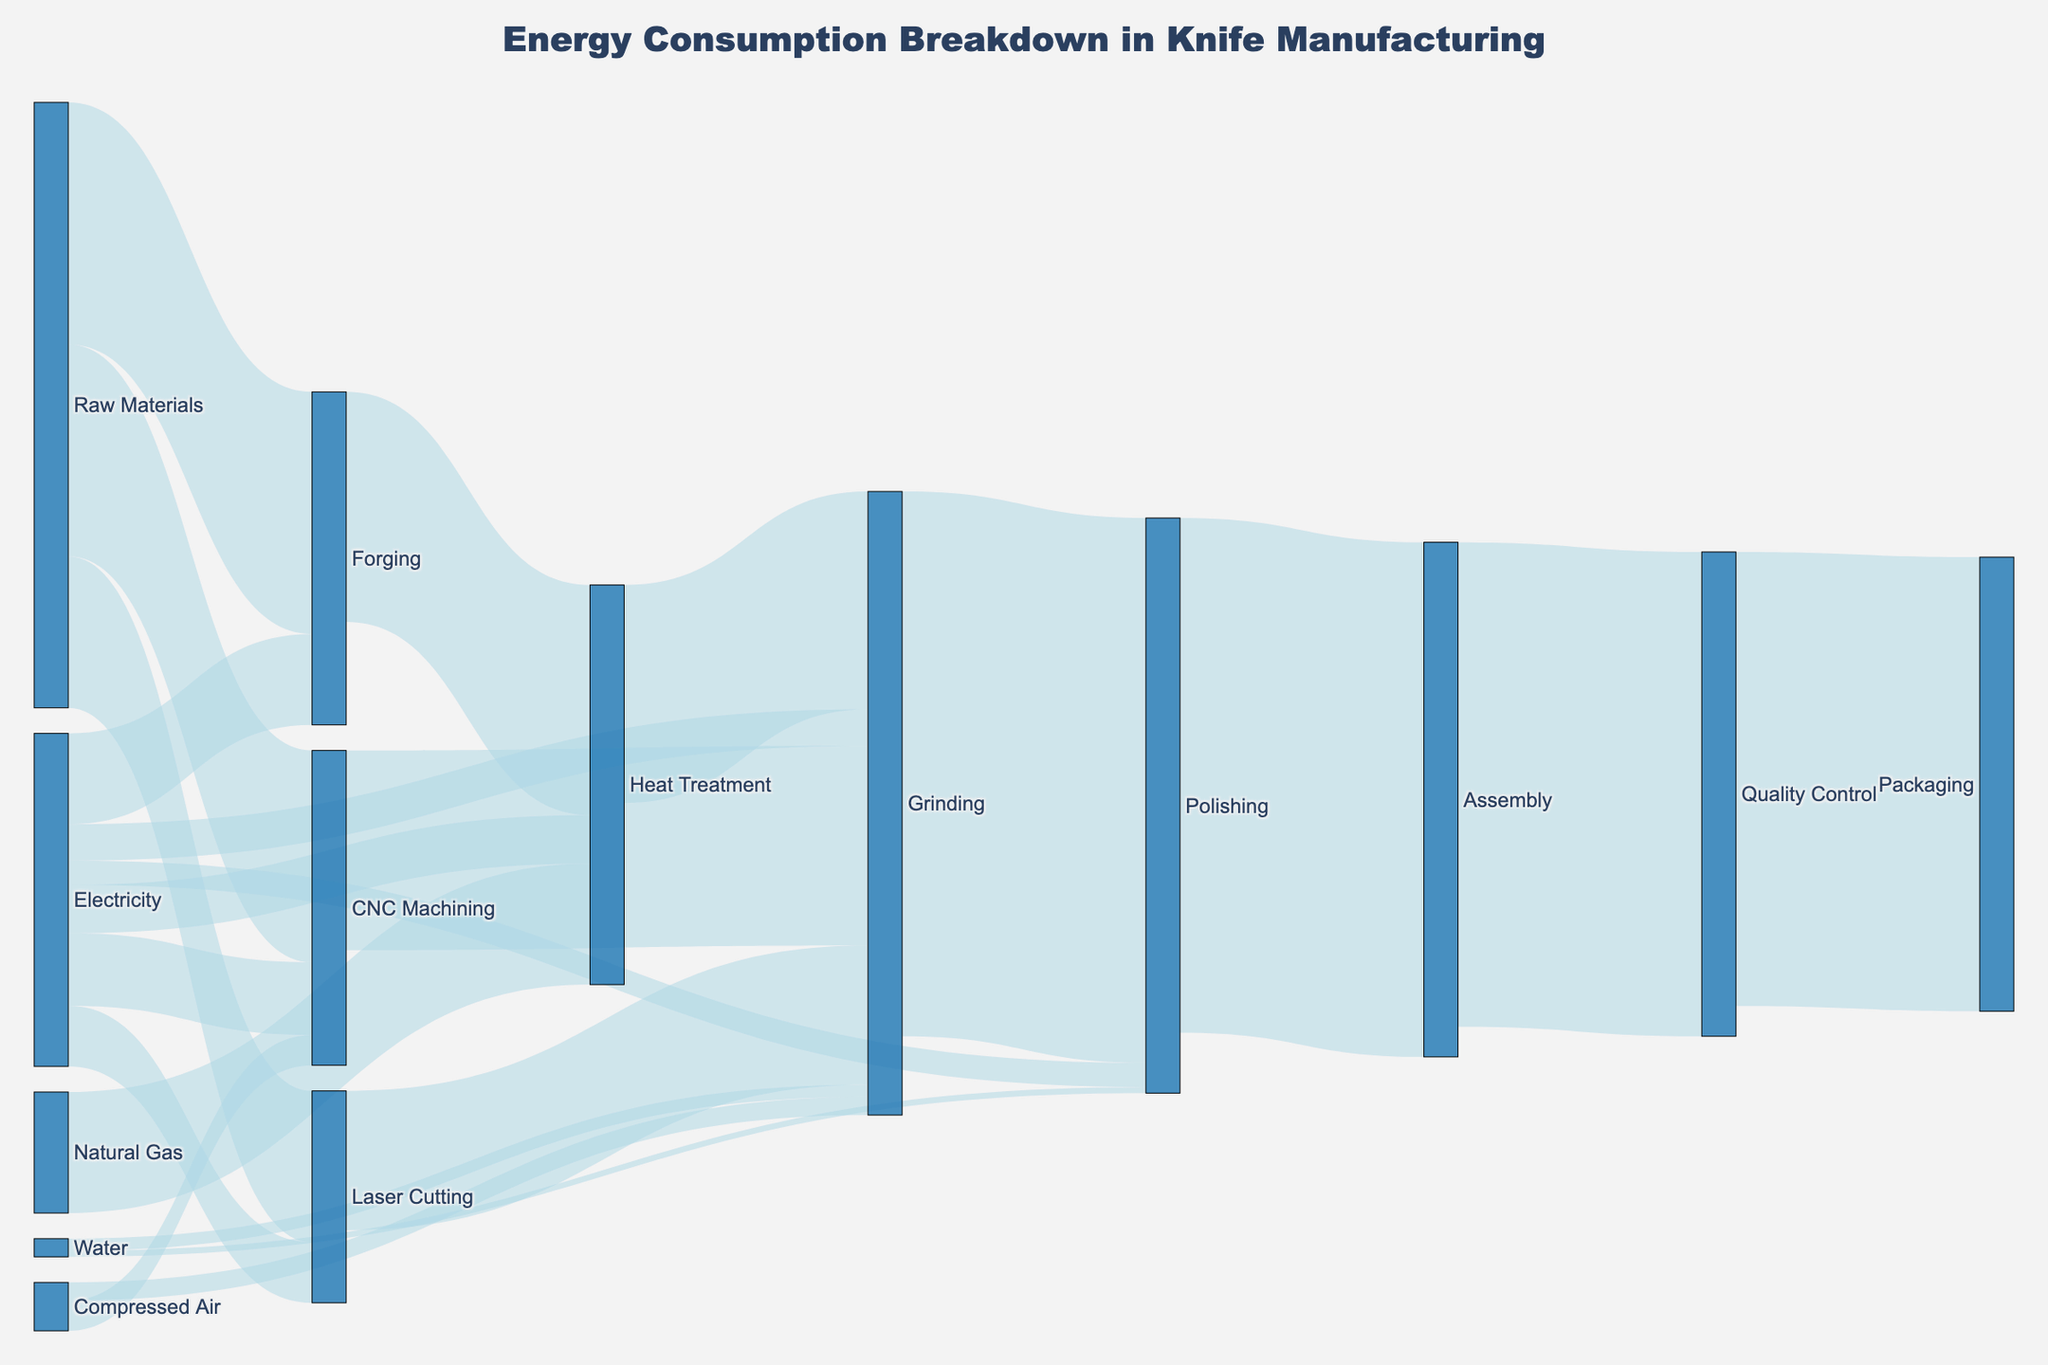What's the title of the figure? The title is usually found at the top center of the figure. In this case, you can see the text "Energy Consumption Breakdown in Knife Manufacturing" prominently displayed as the title.
Answer: Energy Consumption Breakdown in Knife Manufacturing How many categories are involved in the initial energy inputs? Look at the nodes connected directly to sources without any intermediate steps. Count the distinct initial input categories such as Raw Materials, Electricity, Natural Gas, Compressed Air, and Water.
Answer: 5 Which process receives the most energy flow directly from Raw Materials? Identify the nodes connected directly from "Raw Materials" and compare the values shown on the links. "Forging" with 40 units has the highest value.
Answer: Forging What is the total energy consumed during Grinding? Sum the values of all energy flows into Grinding, including from Forging (38), Laser Cutting (23), CNC Machining (33), Electricity (6), Compressed Air (3), and Water (2). So, 38 + 23 + 33 + 6 + 3 + 2 = 105 units.
Answer: 105 Of the processes that use Electricity, which one uses the least? Review the nodes connected to Electricity and compare the linked values. "Polishing" with 4 units has the least consumption.
Answer: Polishing Compare the energy usage between Quality Control and Packaging. Which consumes more? Look at the values of energy flows into Quality Control (80 units) and Packaging (75 units). Since 80 is greater than 75, Quality Control consumes more.
Answer: Quality Control From which processes does Polishing receive energy? Identify the nodes with links directing into Polishing. These are Grinding (with 90 units) and Electricity (with 4 units), and Water (with 1 unit).
Answer: Grinding, Electricity, and Water What is the total energy output from Grinding? Sum all the energy flows outgoing from Grinding, which are to Polishing (90 units). Therefore, the total output is 90 units.
Answer: 90 Which process has the most complex energy input composition, involving multiple sources? Analyze the number of different sources linked to each node. "Grinding" receives energy from Forging, Laser Cutting, CNC Machining, Electricity, Compressed Air, and Water, making it the most complex.
Answer: Grinding What is the main energy source for Heat Treatment? Compare the flow values into Heat Treatment from different sources. "Forging" provides 38 units compared to 8 units from Electricity and 20 units from Natural Gas. Thus, the main source is Forging.
Answer: Forging 